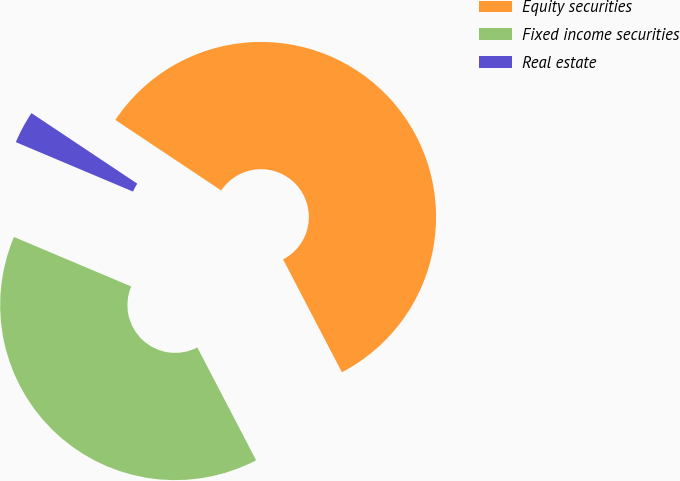<chart> <loc_0><loc_0><loc_500><loc_500><pie_chart><fcel>Equity securities<fcel>Fixed income securities<fcel>Real estate<nl><fcel>58.0%<fcel>39.0%<fcel>3.0%<nl></chart> 